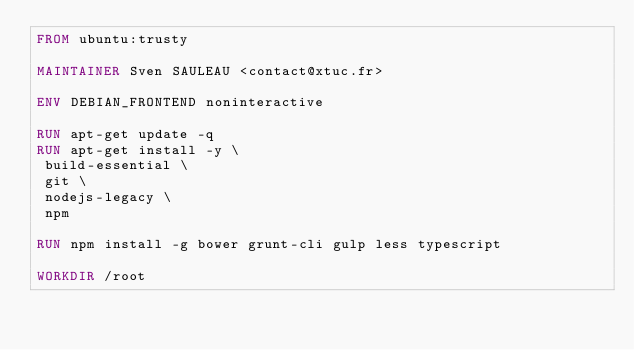<code> <loc_0><loc_0><loc_500><loc_500><_Dockerfile_>FROM ubuntu:trusty

MAINTAINER Sven SAULEAU <contact@xtuc.fr>

ENV DEBIAN_FRONTEND noninteractive

RUN apt-get update -q
RUN apt-get install -y \
 build-essential \
 git \
 nodejs-legacy \
 npm

RUN npm install -g bower grunt-cli gulp less typescript

WORKDIR /root
</code> 